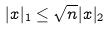<formula> <loc_0><loc_0><loc_500><loc_500>| x | _ { 1 } \leq \sqrt { n } | x | _ { 2 }</formula> 